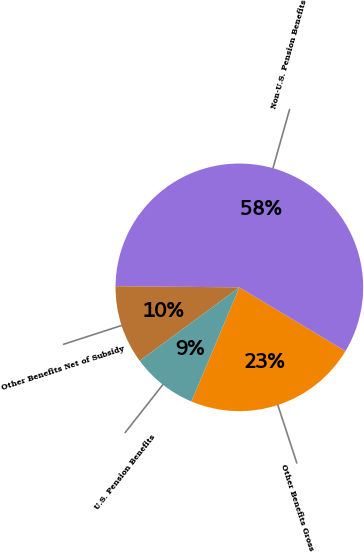Convert chart. <chart><loc_0><loc_0><loc_500><loc_500><pie_chart><fcel>Other Benefits Gross<fcel>Non-U.S. Pension Benefits<fcel>Other Benefits Net of Subsidy<fcel>U.S. Pension Benefits<nl><fcel>22.71%<fcel>58.47%<fcel>10.26%<fcel>8.56%<nl></chart> 